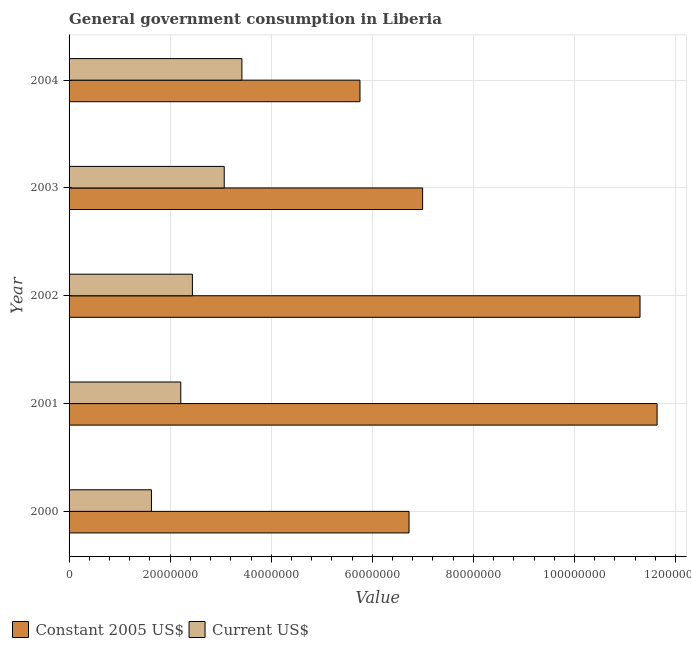Are the number of bars per tick equal to the number of legend labels?
Your answer should be compact. Yes. Are the number of bars on each tick of the Y-axis equal?
Give a very brief answer. Yes. How many bars are there on the 5th tick from the bottom?
Give a very brief answer. 2. What is the value consumed in current us$ in 2000?
Offer a terse response. 1.63e+07. Across all years, what is the maximum value consumed in constant 2005 us$?
Offer a very short reply. 1.16e+08. Across all years, what is the minimum value consumed in current us$?
Keep it short and to the point. 1.63e+07. In which year was the value consumed in current us$ minimum?
Give a very brief answer. 2000. What is the total value consumed in constant 2005 us$ in the graph?
Your response must be concise. 4.24e+08. What is the difference between the value consumed in constant 2005 us$ in 2000 and that in 2001?
Your response must be concise. -4.91e+07. What is the difference between the value consumed in current us$ in 2002 and the value consumed in constant 2005 us$ in 2003?
Your response must be concise. -4.56e+07. What is the average value consumed in constant 2005 us$ per year?
Provide a succinct answer. 8.48e+07. In the year 2004, what is the difference between the value consumed in constant 2005 us$ and value consumed in current us$?
Offer a very short reply. 2.34e+07. In how many years, is the value consumed in current us$ greater than 112000000 ?
Make the answer very short. 0. What is the ratio of the value consumed in constant 2005 us$ in 2000 to that in 2004?
Keep it short and to the point. 1.17. Is the value consumed in current us$ in 2002 less than that in 2004?
Provide a succinct answer. Yes. What is the difference between the highest and the second highest value consumed in constant 2005 us$?
Provide a short and direct response. 3.38e+06. What is the difference between the highest and the lowest value consumed in constant 2005 us$?
Offer a terse response. 5.88e+07. What does the 1st bar from the top in 2002 represents?
Provide a succinct answer. Current US$. What does the 2nd bar from the bottom in 2002 represents?
Your answer should be compact. Current US$. Does the graph contain any zero values?
Provide a short and direct response. No. Where does the legend appear in the graph?
Offer a very short reply. Bottom left. How are the legend labels stacked?
Provide a succinct answer. Horizontal. What is the title of the graph?
Make the answer very short. General government consumption in Liberia. What is the label or title of the X-axis?
Your answer should be compact. Value. What is the label or title of the Y-axis?
Your answer should be very brief. Year. What is the Value of Constant 2005 US$ in 2000?
Your answer should be compact. 6.73e+07. What is the Value of Current US$ in 2000?
Your answer should be compact. 1.63e+07. What is the Value of Constant 2005 US$ in 2001?
Provide a short and direct response. 1.16e+08. What is the Value of Current US$ in 2001?
Offer a terse response. 2.21e+07. What is the Value in Constant 2005 US$ in 2002?
Provide a short and direct response. 1.13e+08. What is the Value in Current US$ in 2002?
Provide a short and direct response. 2.44e+07. What is the Value in Constant 2005 US$ in 2003?
Provide a short and direct response. 7.00e+07. What is the Value of Current US$ in 2003?
Keep it short and to the point. 3.07e+07. What is the Value in Constant 2005 US$ in 2004?
Give a very brief answer. 5.76e+07. What is the Value in Current US$ in 2004?
Provide a short and direct response. 3.42e+07. Across all years, what is the maximum Value of Constant 2005 US$?
Give a very brief answer. 1.16e+08. Across all years, what is the maximum Value of Current US$?
Your response must be concise. 3.42e+07. Across all years, what is the minimum Value in Constant 2005 US$?
Your answer should be very brief. 5.76e+07. Across all years, what is the minimum Value of Current US$?
Give a very brief answer. 1.63e+07. What is the total Value of Constant 2005 US$ in the graph?
Your answer should be very brief. 4.24e+08. What is the total Value in Current US$ in the graph?
Provide a short and direct response. 1.28e+08. What is the difference between the Value of Constant 2005 US$ in 2000 and that in 2001?
Keep it short and to the point. -4.91e+07. What is the difference between the Value of Current US$ in 2000 and that in 2001?
Your answer should be very brief. -5.80e+06. What is the difference between the Value in Constant 2005 US$ in 2000 and that in 2002?
Provide a succinct answer. -4.57e+07. What is the difference between the Value of Current US$ in 2000 and that in 2002?
Offer a terse response. -8.10e+06. What is the difference between the Value in Constant 2005 US$ in 2000 and that in 2003?
Provide a short and direct response. -2.69e+06. What is the difference between the Value in Current US$ in 2000 and that in 2003?
Make the answer very short. -1.44e+07. What is the difference between the Value in Constant 2005 US$ in 2000 and that in 2004?
Give a very brief answer. 9.70e+06. What is the difference between the Value in Current US$ in 2000 and that in 2004?
Your response must be concise. -1.79e+07. What is the difference between the Value in Constant 2005 US$ in 2001 and that in 2002?
Give a very brief answer. 3.38e+06. What is the difference between the Value in Current US$ in 2001 and that in 2002?
Offer a terse response. -2.30e+06. What is the difference between the Value of Constant 2005 US$ in 2001 and that in 2003?
Make the answer very short. 4.64e+07. What is the difference between the Value of Current US$ in 2001 and that in 2003?
Your answer should be compact. -8.60e+06. What is the difference between the Value of Constant 2005 US$ in 2001 and that in 2004?
Offer a terse response. 5.88e+07. What is the difference between the Value in Current US$ in 2001 and that in 2004?
Provide a succinct answer. -1.21e+07. What is the difference between the Value of Constant 2005 US$ in 2002 and that in 2003?
Provide a short and direct response. 4.30e+07. What is the difference between the Value of Current US$ in 2002 and that in 2003?
Offer a terse response. -6.30e+06. What is the difference between the Value of Constant 2005 US$ in 2002 and that in 2004?
Make the answer very short. 5.54e+07. What is the difference between the Value in Current US$ in 2002 and that in 2004?
Offer a terse response. -9.80e+06. What is the difference between the Value in Constant 2005 US$ in 2003 and that in 2004?
Keep it short and to the point. 1.24e+07. What is the difference between the Value of Current US$ in 2003 and that in 2004?
Provide a short and direct response. -3.50e+06. What is the difference between the Value of Constant 2005 US$ in 2000 and the Value of Current US$ in 2001?
Offer a very short reply. 4.52e+07. What is the difference between the Value in Constant 2005 US$ in 2000 and the Value in Current US$ in 2002?
Your answer should be compact. 4.29e+07. What is the difference between the Value of Constant 2005 US$ in 2000 and the Value of Current US$ in 2003?
Your answer should be compact. 3.66e+07. What is the difference between the Value in Constant 2005 US$ in 2000 and the Value in Current US$ in 2004?
Your answer should be compact. 3.31e+07. What is the difference between the Value in Constant 2005 US$ in 2001 and the Value in Current US$ in 2002?
Keep it short and to the point. 9.20e+07. What is the difference between the Value in Constant 2005 US$ in 2001 and the Value in Current US$ in 2003?
Your response must be concise. 8.57e+07. What is the difference between the Value in Constant 2005 US$ in 2001 and the Value in Current US$ in 2004?
Offer a very short reply. 8.22e+07. What is the difference between the Value in Constant 2005 US$ in 2002 and the Value in Current US$ in 2003?
Give a very brief answer. 8.23e+07. What is the difference between the Value of Constant 2005 US$ in 2002 and the Value of Current US$ in 2004?
Make the answer very short. 7.88e+07. What is the difference between the Value of Constant 2005 US$ in 2003 and the Value of Current US$ in 2004?
Your response must be concise. 3.58e+07. What is the average Value of Constant 2005 US$ per year?
Make the answer very short. 8.48e+07. What is the average Value in Current US$ per year?
Your response must be concise. 2.55e+07. In the year 2000, what is the difference between the Value of Constant 2005 US$ and Value of Current US$?
Your answer should be very brief. 5.10e+07. In the year 2001, what is the difference between the Value in Constant 2005 US$ and Value in Current US$?
Your response must be concise. 9.43e+07. In the year 2002, what is the difference between the Value in Constant 2005 US$ and Value in Current US$?
Give a very brief answer. 8.86e+07. In the year 2003, what is the difference between the Value of Constant 2005 US$ and Value of Current US$?
Your response must be concise. 3.93e+07. In the year 2004, what is the difference between the Value of Constant 2005 US$ and Value of Current US$?
Ensure brevity in your answer.  2.34e+07. What is the ratio of the Value of Constant 2005 US$ in 2000 to that in 2001?
Give a very brief answer. 0.58. What is the ratio of the Value in Current US$ in 2000 to that in 2001?
Make the answer very short. 0.74. What is the ratio of the Value in Constant 2005 US$ in 2000 to that in 2002?
Your response must be concise. 0.6. What is the ratio of the Value of Current US$ in 2000 to that in 2002?
Offer a very short reply. 0.67. What is the ratio of the Value in Constant 2005 US$ in 2000 to that in 2003?
Offer a terse response. 0.96. What is the ratio of the Value of Current US$ in 2000 to that in 2003?
Offer a very short reply. 0.53. What is the ratio of the Value of Constant 2005 US$ in 2000 to that in 2004?
Ensure brevity in your answer.  1.17. What is the ratio of the Value in Current US$ in 2000 to that in 2004?
Your answer should be compact. 0.48. What is the ratio of the Value of Constant 2005 US$ in 2001 to that in 2002?
Make the answer very short. 1.03. What is the ratio of the Value in Current US$ in 2001 to that in 2002?
Your answer should be compact. 0.91. What is the ratio of the Value in Constant 2005 US$ in 2001 to that in 2003?
Make the answer very short. 1.66. What is the ratio of the Value in Current US$ in 2001 to that in 2003?
Your answer should be compact. 0.72. What is the ratio of the Value in Constant 2005 US$ in 2001 to that in 2004?
Give a very brief answer. 2.02. What is the ratio of the Value in Current US$ in 2001 to that in 2004?
Make the answer very short. 0.65. What is the ratio of the Value of Constant 2005 US$ in 2002 to that in 2003?
Keep it short and to the point. 1.61. What is the ratio of the Value of Current US$ in 2002 to that in 2003?
Your answer should be compact. 0.79. What is the ratio of the Value in Constant 2005 US$ in 2002 to that in 2004?
Offer a terse response. 1.96. What is the ratio of the Value of Current US$ in 2002 to that in 2004?
Your response must be concise. 0.71. What is the ratio of the Value of Constant 2005 US$ in 2003 to that in 2004?
Give a very brief answer. 1.22. What is the ratio of the Value in Current US$ in 2003 to that in 2004?
Give a very brief answer. 0.9. What is the difference between the highest and the second highest Value in Constant 2005 US$?
Your answer should be very brief. 3.38e+06. What is the difference between the highest and the second highest Value of Current US$?
Your answer should be very brief. 3.50e+06. What is the difference between the highest and the lowest Value in Constant 2005 US$?
Offer a very short reply. 5.88e+07. What is the difference between the highest and the lowest Value of Current US$?
Offer a terse response. 1.79e+07. 